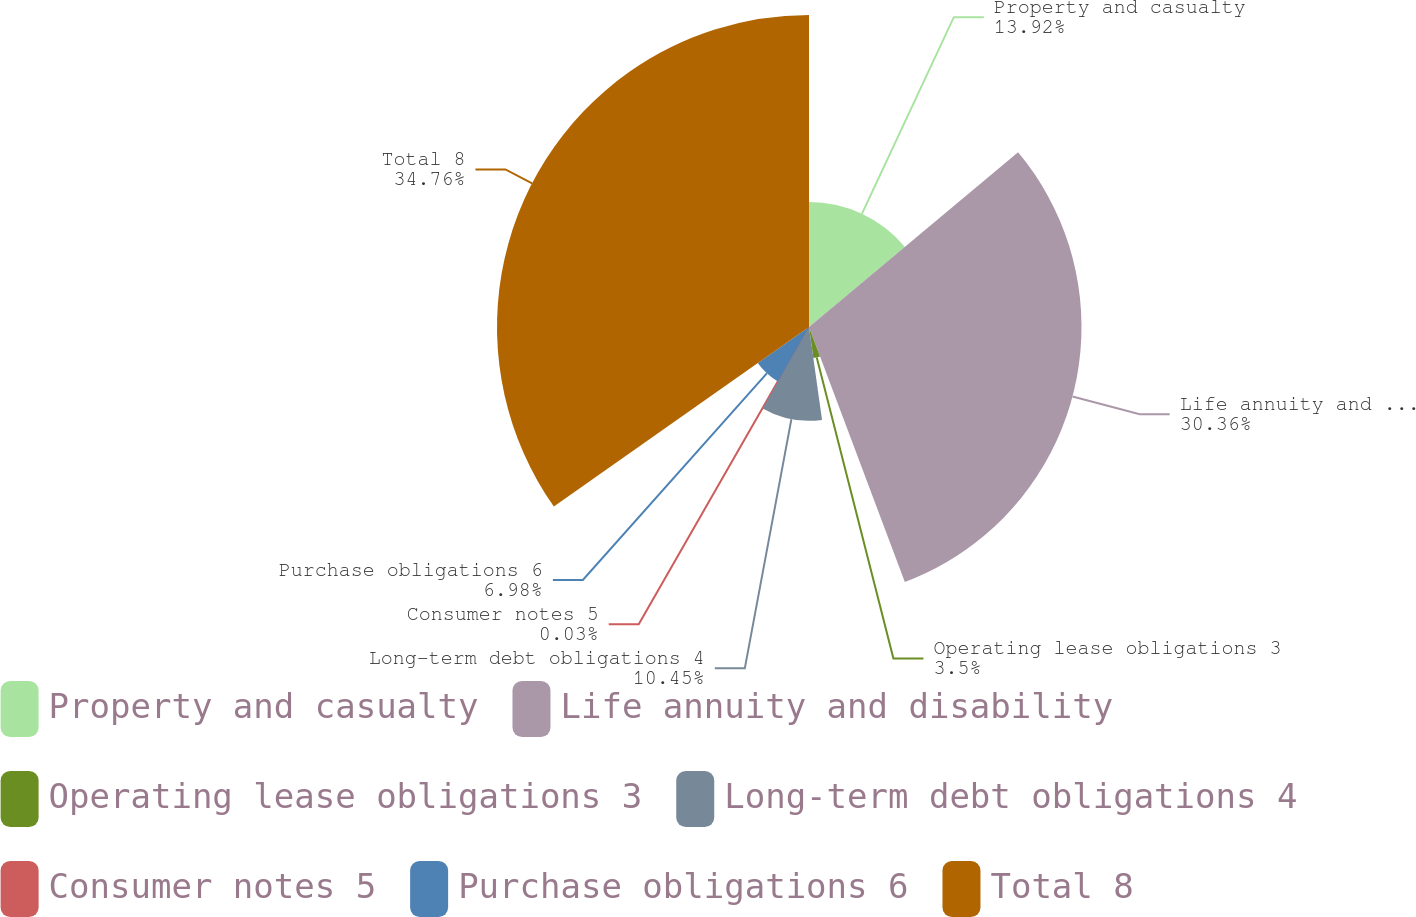Convert chart. <chart><loc_0><loc_0><loc_500><loc_500><pie_chart><fcel>Property and casualty<fcel>Life annuity and disability<fcel>Operating lease obligations 3<fcel>Long-term debt obligations 4<fcel>Consumer notes 5<fcel>Purchase obligations 6<fcel>Total 8<nl><fcel>13.92%<fcel>30.36%<fcel>3.5%<fcel>10.45%<fcel>0.03%<fcel>6.98%<fcel>34.76%<nl></chart> 